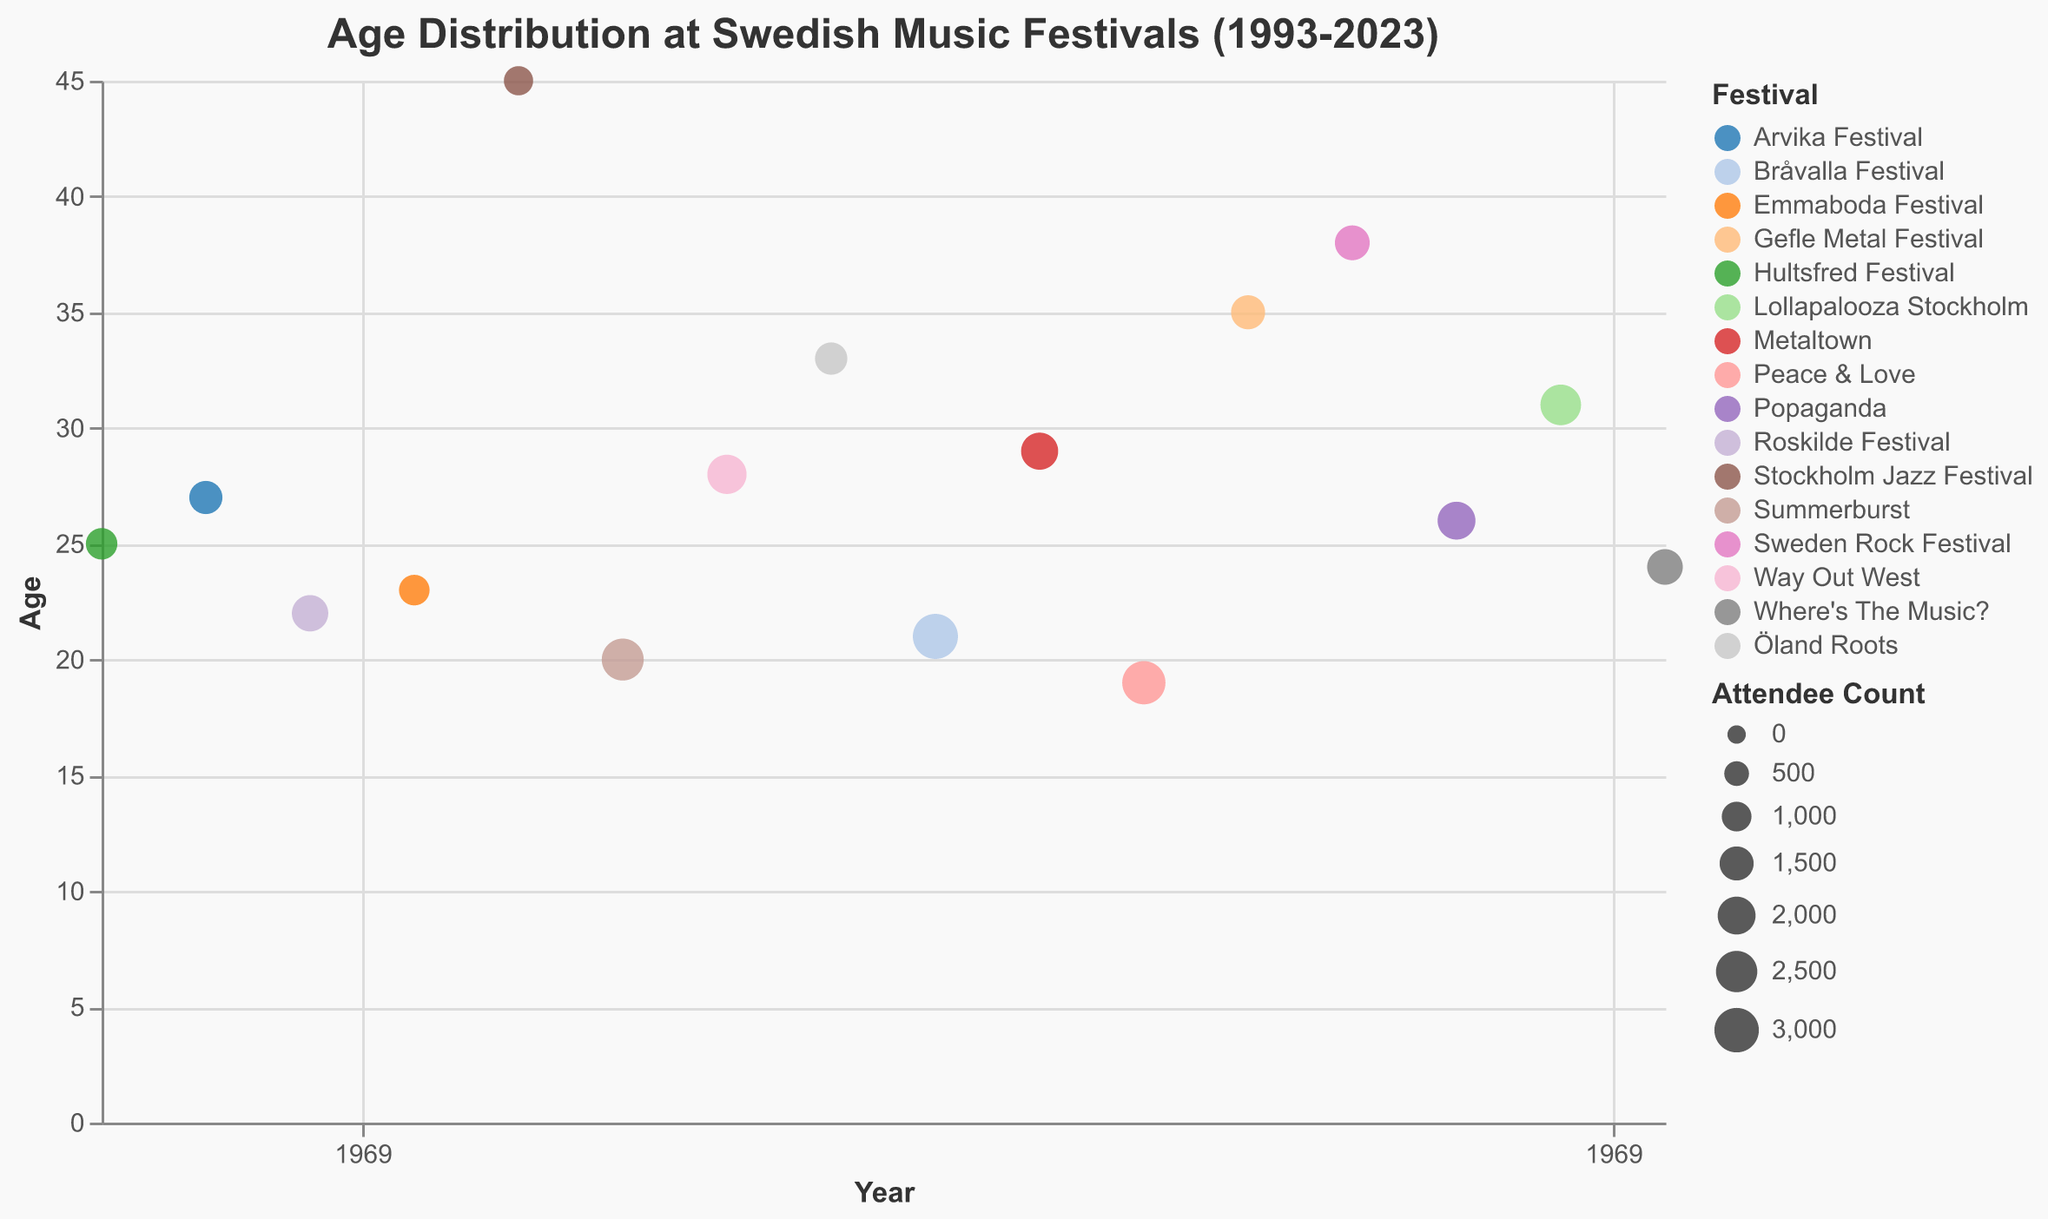What's the title of the figure? The title of the figure is displayed at the top.
Answer: Age Distribution at Swedish Music Festivals (1993-2023) How many festivals are depicted in the plot? By counting the different colors in the legend or examining unique festival names on the plot, we see there are 16 festivals shown.
Answer: 16 Which festival had the oldest average age of attendees? By examining the y-axis positions of the points and tooltip information, the Stockholm Jazz Festival in 2001 had the oldest attendees with an age of 45.
Answer: Stockholm Jazz Festival What is the age range of attendees at the 2023 festival? Locate "Where's The Music?" on the x-axis at 2023 and check the y-axis position to see the age value, which is 24. The range is 24 to 24 as it's a single data point.
Answer: 24 Which year had the highest age difference between any two festivals? By comparing the y-values in each year, 2001 shows a large age difference between Stockholm Jazz Festival (45) and Summerburst (20), making the difference 25 years.
Answer: 2001 What is the average age of attendees across all festivals? Sum the ages (25+22+45+28+21+19+38+31+27+23+20+33+29+35+26+24) which is 446, and divide by the number of festivals (16). The average age is 446/16 = 27.875.
Answer: 27.9 Which festival had the highest attendee count and what was their age? By checking the tooltip data or the size of the points, Bråvalla Festival in 2009 had the highest attendee count of 3100, and their age was 21.
Answer: Bråvalla Festival, 21 Are the ages of festival attendees generally increasing or decreasing over the years? Visually tracking the general trend of the points on the y-axis from left to right (1993 to 2023) shows no clear increasing or decreasing pattern.
Answer: No clear trend Which festival in 2017 had its attendees' average age close to 38? Finding the point corresponding to 2017 and examining its details reveals that Sweden Rock Festival had an attendee age of 38.
Answer: Sweden Rock Festival How does the age of attendees at the Roskilde Festival in 1997 compare to those at Lollapalooza Stockholm in 2021? In 1997, Roskilde Festival's attendees were 22 years old, and in 2021, Lollapalooza Stockholm's attendees were 31 years old. 31 is higher than 22 by 9 years.
Answer: 9 years higher in 2021 